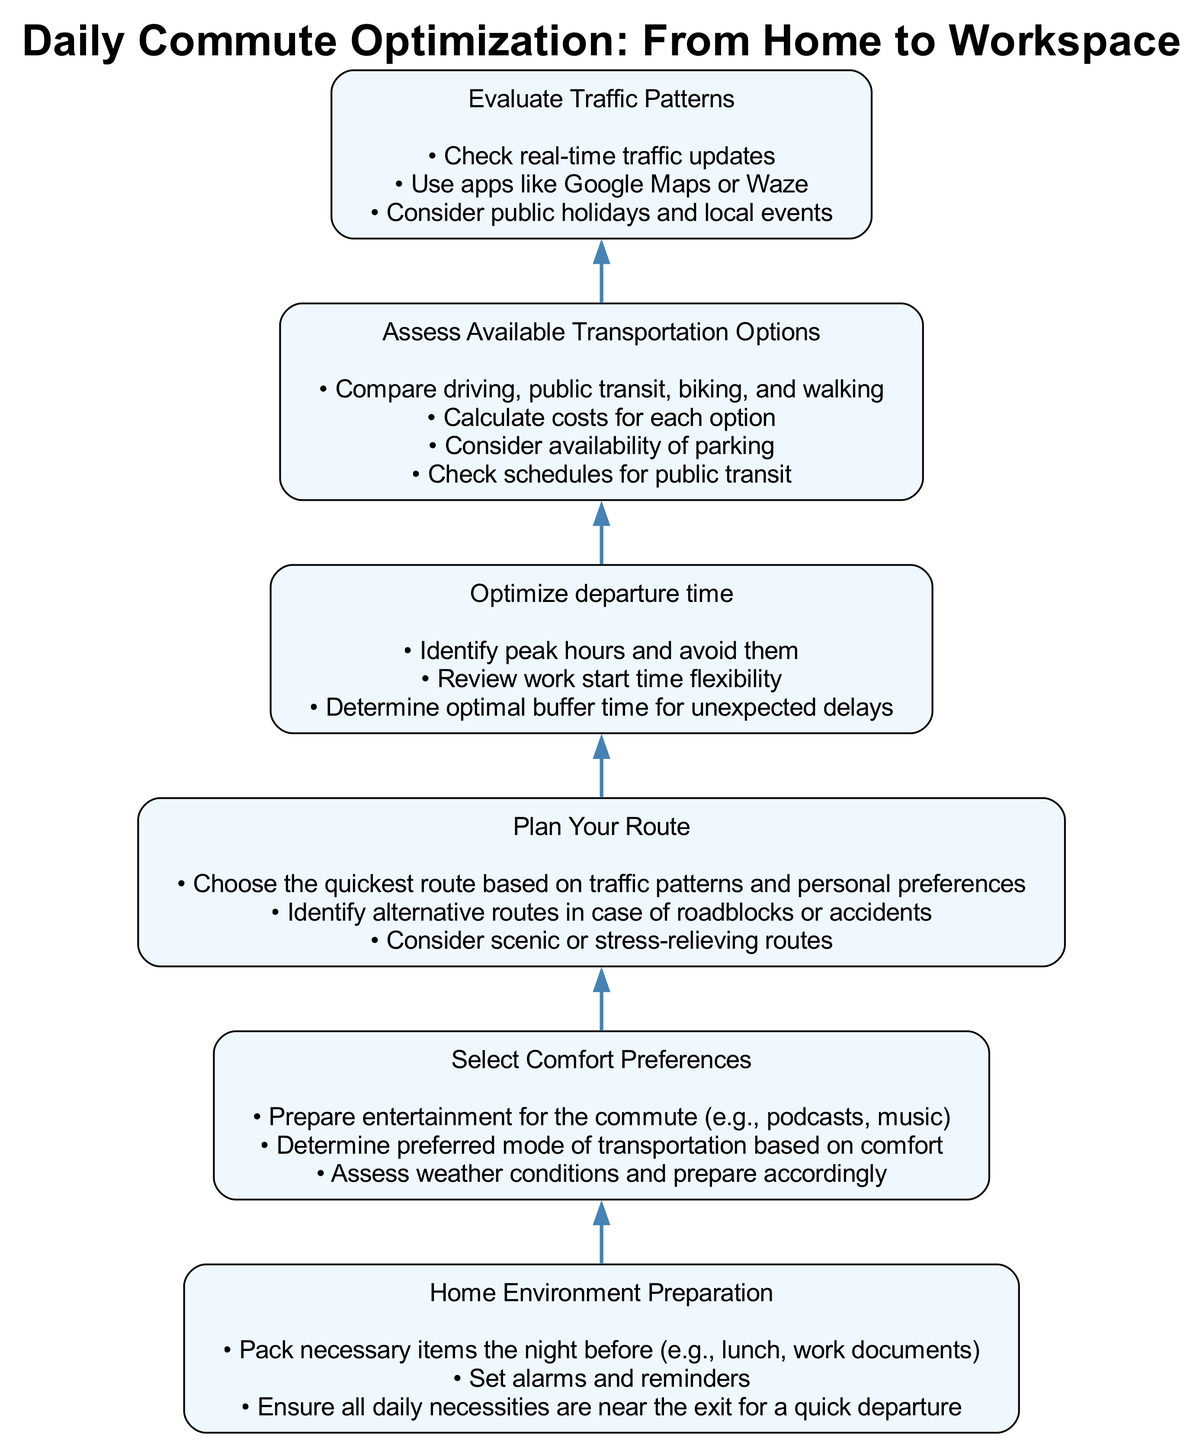What is the first step in the diagram? The first step in the diagram is "Home Environment Preparation," which is at the bottom of the flowchart.
Answer: Home Environment Preparation How many steps are there in total? There are six steps listed in the diagram, which can be counted from the bottom to the top.
Answer: 6 What step comes immediately after "Select Comfort Preferences"? The step that comes immediately after "Select Comfort Preferences" is "Plan Your Route," indicating the flow from the chosen comfort preferences to the planning of the route.
Answer: Plan Your Route Which step includes checking traffic updates? The step that includes checking traffic updates is "Evaluate Traffic Patterns," which specifically mentions using apps like Google Maps or Waze as part of its details.
Answer: Evaluate Traffic Patterns What is the relationship between "Optimize departure time" and "Plan Your Route"? "Optimize departure time" is directly above "Plan Your Route" in the flowchart, indicating that optimizing the departure timing influences the route planning process, suggesting a logical sequence.
Answer: Optimize departure time influences Plan Your Route What factors are considered when assessing available transportation options? The factors considered include comparing driving, public transit, biking, and walking, calculating costs, availability of parking, and checking public transit schedules according to the details provided for that step.
Answer: Compare driving, public transit, biking, walking, calculate costs, availability of parking, check schedules Which step suggests avoiding peak hours? The step that suggests avoiding peak hours is "Optimize departure time," which specifically mentions identifying peak hours and looking at the work start time flexibility.
Answer: Optimize departure time What alternative does "Plan Your Route" mention regarding roadblocks? "Plan Your Route" mentions identifying alternative routes in case of roadblocks or accidents as part of the planning process.
Answer: Identify alternative routes In which step are entertainment options prepared? Entertainment options are prepared in the step "Select Comfort Preferences," which advises on preparing entertainment for the commute, such as podcasts or music.
Answer: Select Comfort Preferences 